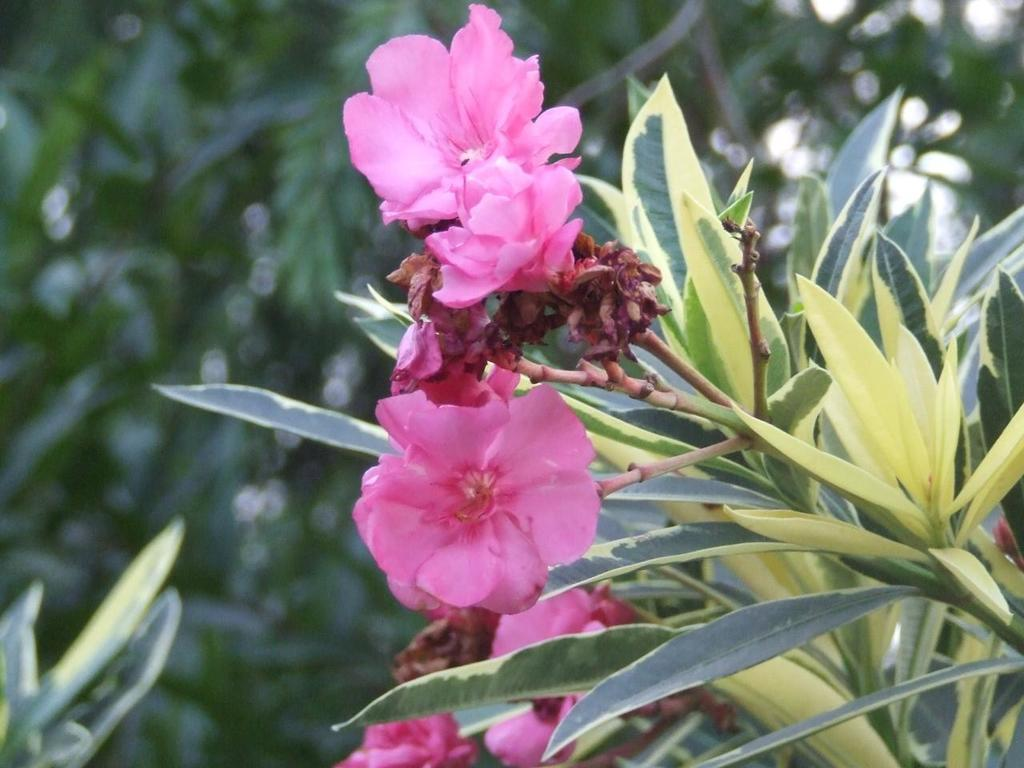What type of plant is visible in the image? There is a plant in the image. What is the color of the plant? The plant is green in color. What additional features can be seen on the plant? There are flowers on the plant. What is the color of the flowers? The flowers are pink in color. What can be seen in the background of the image? There are trees in the background of the image. What is the color of the trees? The trees are green in color. How does the plant participate in the competition in the image? There is no competition present in the image; it is a plant with flowers and trees in the background. 